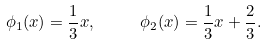Convert formula to latex. <formula><loc_0><loc_0><loc_500><loc_500>\phi _ { 1 } ( x ) = \frac { 1 } { 3 } x , \quad & \quad \phi _ { 2 } ( x ) = \frac { 1 } { 3 } x + \frac { 2 } { 3 } .</formula> 